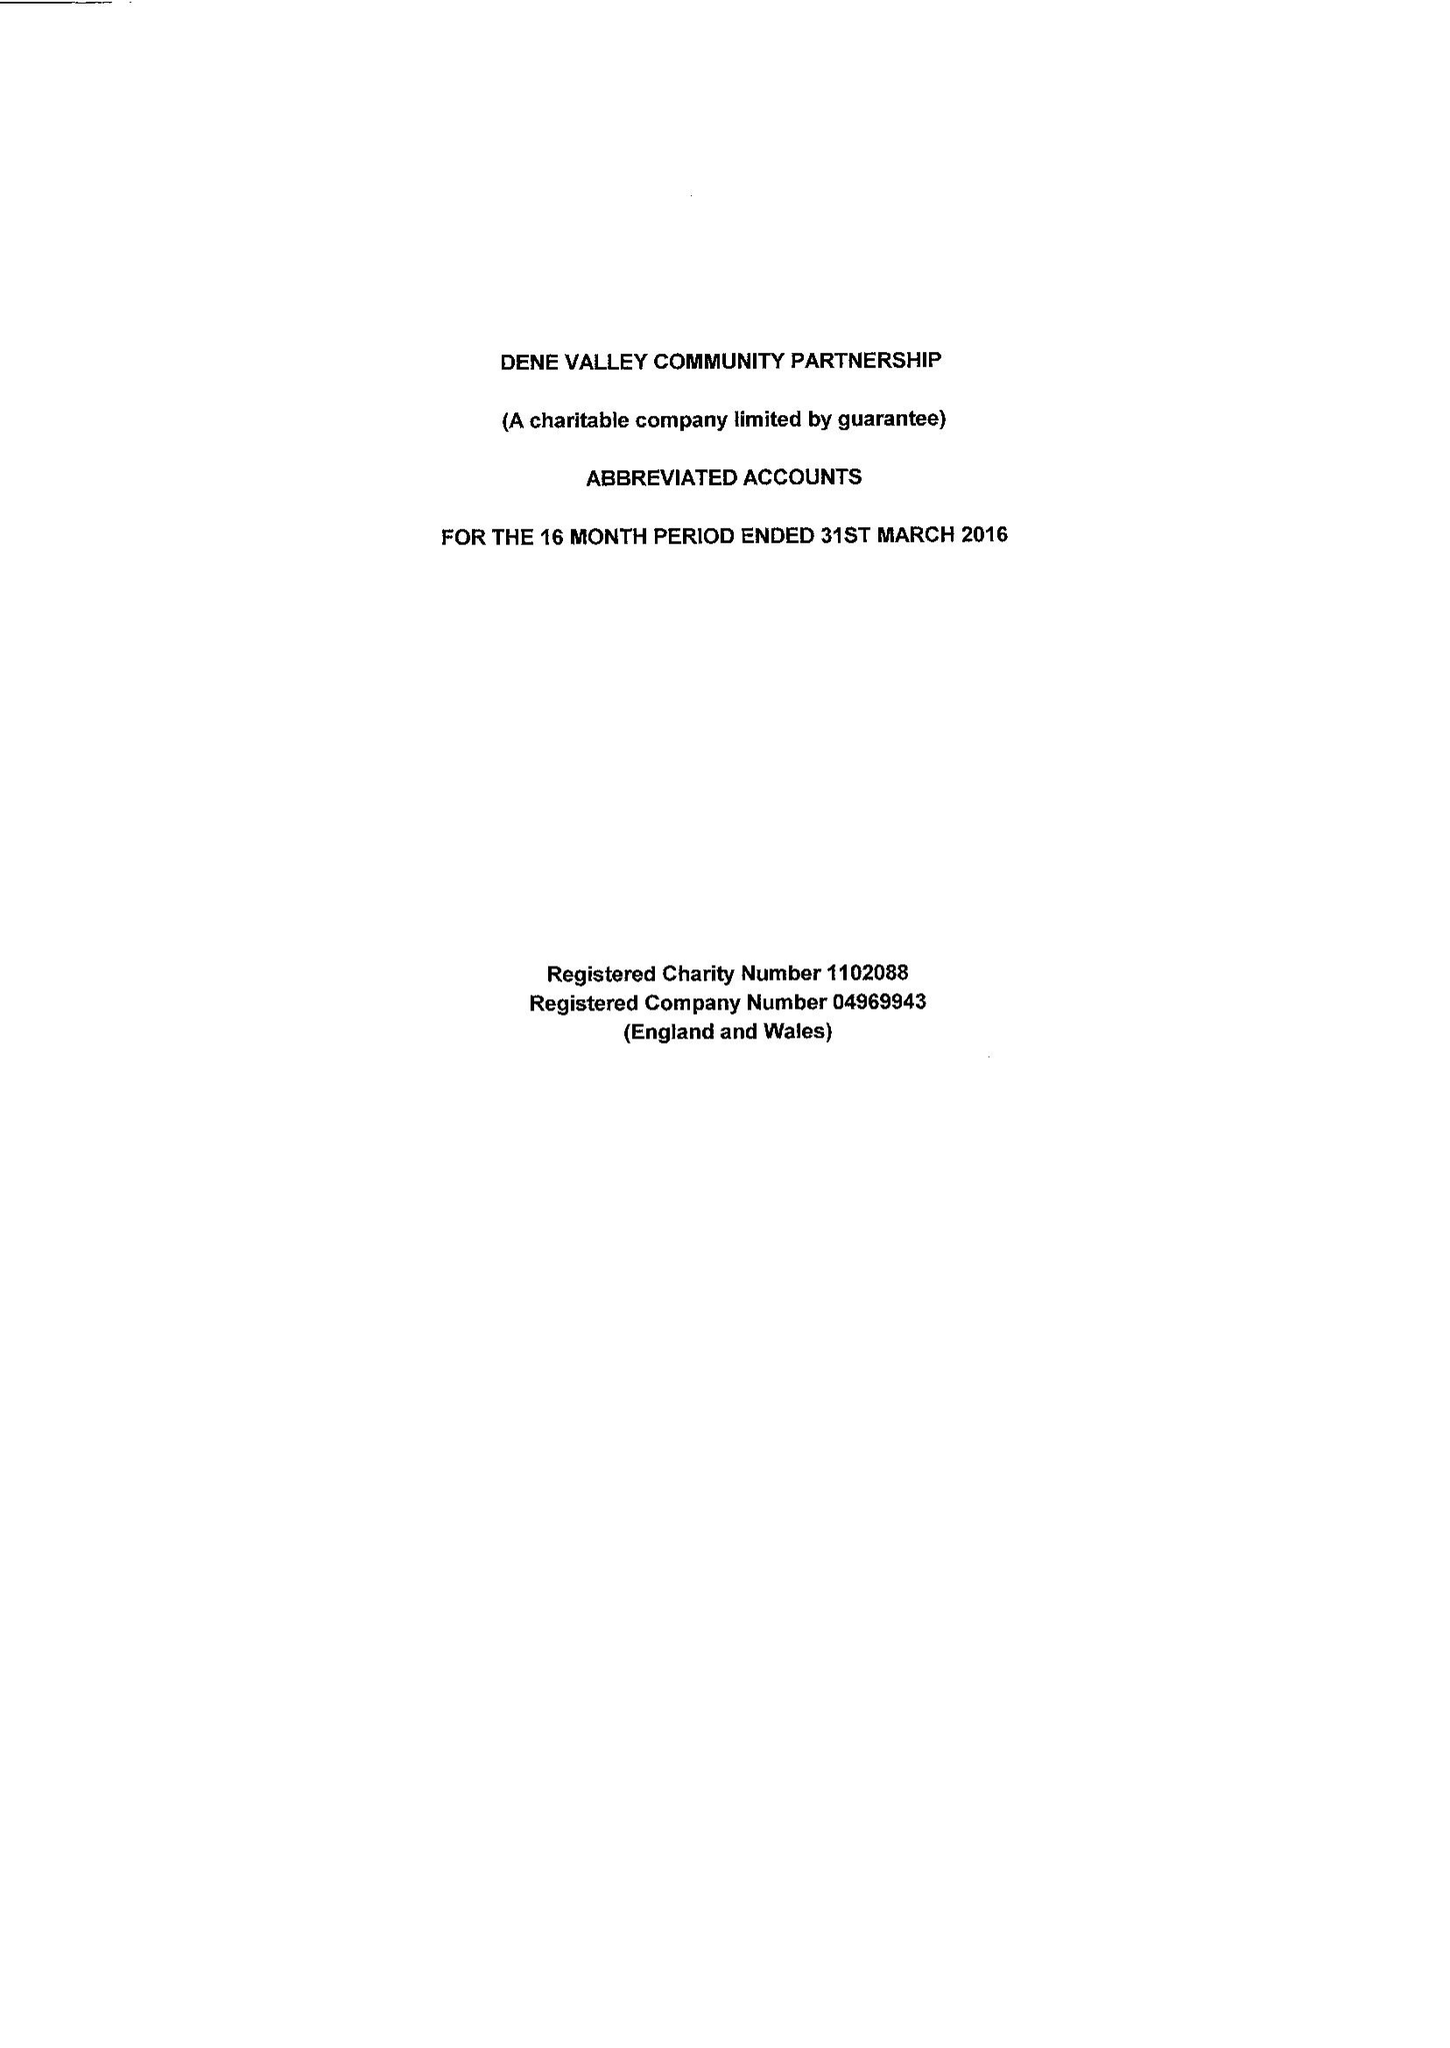What is the value for the address__street_line?
Answer the question using a single word or phrase. 14 HIGH STREET 